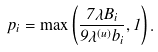<formula> <loc_0><loc_0><loc_500><loc_500>p _ { i } = \max \left ( \frac { 7 \lambda B _ { i } } { 9 \lambda ^ { ( u ) } b _ { i } } , 1 \right ) .</formula> 